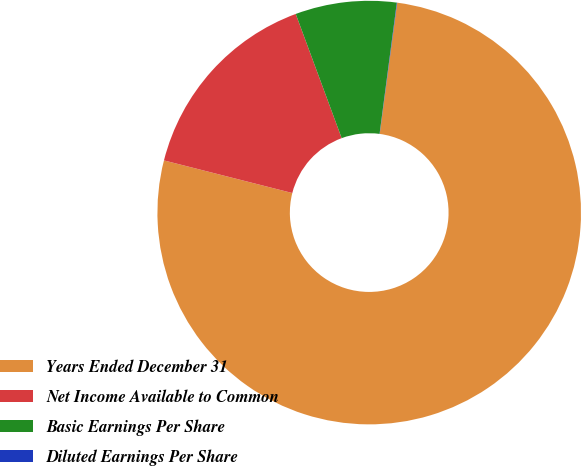<chart> <loc_0><loc_0><loc_500><loc_500><pie_chart><fcel>Years Ended December 31<fcel>Net Income Available to Common<fcel>Basic Earnings Per Share<fcel>Diluted Earnings Per Share<nl><fcel>76.85%<fcel>15.4%<fcel>7.72%<fcel>0.03%<nl></chart> 